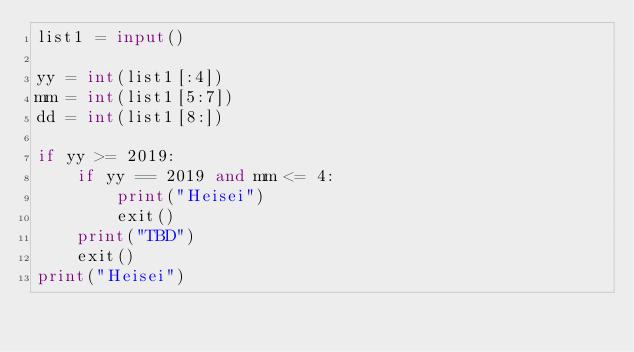<code> <loc_0><loc_0><loc_500><loc_500><_Python_>list1 = input()

yy = int(list1[:4])
mm = int(list1[5:7])
dd = int(list1[8:])

if yy >= 2019:
    if yy == 2019 and mm <= 4:
        print("Heisei")
        exit()
    print("TBD")
    exit()
print("Heisei")</code> 